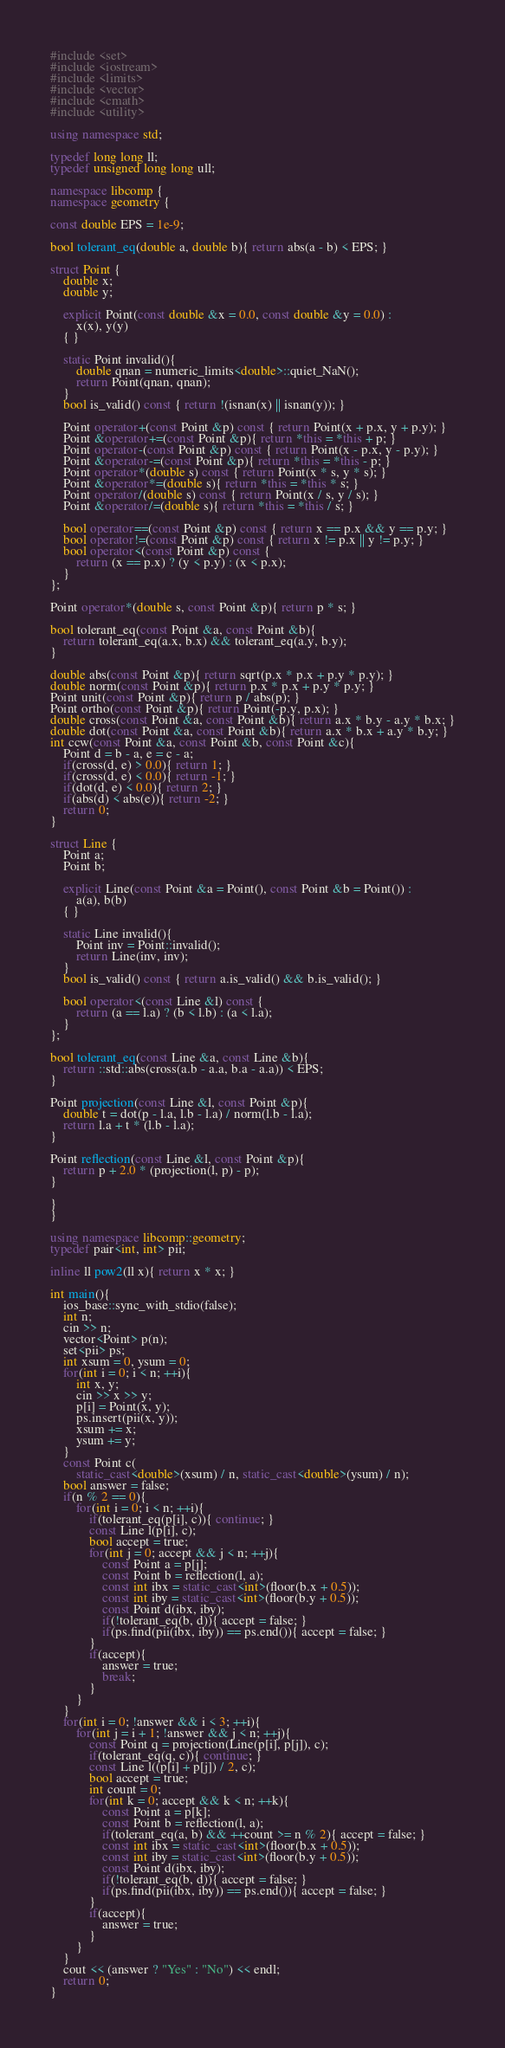Convert code to text. <code><loc_0><loc_0><loc_500><loc_500><_C++_>#include <set>
#include <iostream>
#include <limits>
#include <vector>
#include <cmath>
#include <utility>

using namespace std;

typedef long long ll;
typedef unsigned long long ull;

namespace libcomp {
namespace geometry {

const double EPS = 1e-9;

bool tolerant_eq(double a, double b){ return abs(a - b) < EPS; }

struct Point {
	double x;
	double y;

	explicit Point(const double &x = 0.0, const double &y = 0.0) :
		x(x), y(y)
	{ }

	static Point invalid(){
		double qnan = numeric_limits<double>::quiet_NaN();
		return Point(qnan, qnan);
	}
	bool is_valid() const { return !(isnan(x) || isnan(y)); }

	Point operator+(const Point &p) const { return Point(x + p.x, y + p.y); }
	Point &operator+=(const Point &p){ return *this = *this + p; }
	Point operator-(const Point &p) const { return Point(x - p.x, y - p.y); }
	Point &operator-=(const Point &p){ return *this = *this - p; }
	Point operator*(double s) const { return Point(x * s, y * s); }
	Point &operator*=(double s){ return *this = *this * s; }
	Point operator/(double s) const { return Point(x / s, y / s); }
	Point &operator/=(double s){ return *this = *this / s; }

	bool operator==(const Point &p) const { return x == p.x && y == p.y; }
	bool operator!=(const Point &p) const { return x != p.x || y != p.y; }
	bool operator<(const Point &p) const {
		return (x == p.x) ? (y < p.y) : (x < p.x);
	}
};

Point operator*(double s, const Point &p){ return p * s; }

bool tolerant_eq(const Point &a, const Point &b){
	return tolerant_eq(a.x, b.x) && tolerant_eq(a.y, b.y);
}

double abs(const Point &p){ return sqrt(p.x * p.x + p.y * p.y); }
double norm(const Point &p){ return p.x * p.x + p.y * p.y; }
Point unit(const Point &p){ return p / abs(p); }
Point ortho(const Point &p){ return Point(-p.y, p.x); }
double cross(const Point &a, const Point &b){ return a.x * b.y - a.y * b.x; }
double dot(const Point &a, const Point &b){ return a.x * b.x + a.y * b.y; }
int ccw(const Point &a, const Point &b, const Point &c){
	Point d = b - a, e = c - a;
	if(cross(d, e) > 0.0){ return 1; }
	if(cross(d, e) < 0.0){ return -1; }
	if(dot(d, e) < 0.0){ return 2; }
	if(abs(d) < abs(e)){ return -2; }
	return 0;
}

struct Line {
	Point a;
	Point b;

	explicit Line(const Point &a = Point(), const Point &b = Point()) :
		a(a), b(b)
	{ }

	static Line invalid(){
		Point inv = Point::invalid();
		return Line(inv, inv);
	}
	bool is_valid() const { return a.is_valid() && b.is_valid(); }

	bool operator<(const Line &l) const {
		return (a == l.a) ? (b < l.b) : (a < l.a);
	}
};

bool tolerant_eq(const Line &a, const Line &b){
	return ::std::abs(cross(a.b - a.a, b.a - a.a)) < EPS;
}

Point projection(const Line &l, const Point &p){
	double t = dot(p - l.a, l.b - l.a) / norm(l.b - l.a);
	return l.a + t * (l.b - l.a);
}

Point reflection(const Line &l, const Point &p){
	return p + 2.0 * (projection(l, p) - p);
}

}
}

using namespace libcomp::geometry;
typedef pair<int, int> pii;

inline ll pow2(ll x){ return x * x; }

int main(){
	ios_base::sync_with_stdio(false);
	int n;
	cin >> n;
	vector<Point> p(n);
	set<pii> ps;
	int xsum = 0, ysum = 0;
	for(int i = 0; i < n; ++i){
		int x, y;
		cin >> x >> y;
		p[i] = Point(x, y);
		ps.insert(pii(x, y));
		xsum += x;
		ysum += y;
	}
	const Point c(
		static_cast<double>(xsum) / n, static_cast<double>(ysum) / n);
	bool answer = false;
	if(n % 2 == 0){
		for(int i = 0; i < n; ++i){
			if(tolerant_eq(p[i], c)){ continue; }
			const Line l(p[i], c);
			bool accept = true;
			for(int j = 0; accept && j < n; ++j){
				const Point a = p[j];
				const Point b = reflection(l, a);
				const int ibx = static_cast<int>(floor(b.x + 0.5));
				const int iby = static_cast<int>(floor(b.y + 0.5));
				const Point d(ibx, iby);
				if(!tolerant_eq(b, d)){ accept = false; }
				if(ps.find(pii(ibx, iby)) == ps.end()){ accept = false; }
			}
			if(accept){
				answer = true;
				break;
			}
		}
	}
	for(int i = 0; !answer && i < 3; ++i){
		for(int j = i + 1; !answer && j < n; ++j){
			const Point q = projection(Line(p[i], p[j]), c);
			if(tolerant_eq(q, c)){ continue; }
			const Line l((p[i] + p[j]) / 2, c);
			bool accept = true;
			int count = 0;
			for(int k = 0; accept && k < n; ++k){
				const Point a = p[k];
				const Point b = reflection(l, a);
				if(tolerant_eq(a, b) && ++count >= n % 2){ accept = false; }
				const int ibx = static_cast<int>(floor(b.x + 0.5));
				const int iby = static_cast<int>(floor(b.y + 0.5));
				const Point d(ibx, iby);
				if(!tolerant_eq(b, d)){ accept = false; }
				if(ps.find(pii(ibx, iby)) == ps.end()){ accept = false; }
			}
			if(accept){
				answer = true;
			}
		}
	}
	cout << (answer ? "Yes" : "No") << endl;
	return 0;
}</code> 